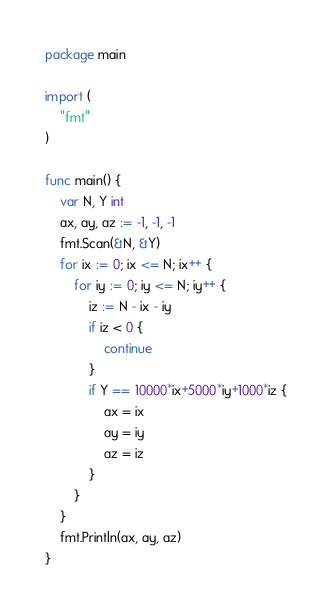<code> <loc_0><loc_0><loc_500><loc_500><_Go_>package main

import (
	"fmt"
)

func main() {
	var N, Y int
	ax, ay, az := -1, -1, -1
	fmt.Scan(&N, &Y)
	for ix := 0; ix <= N; ix++ {
		for iy := 0; iy <= N; iy++ {
			iz := N - ix - iy
			if iz < 0 {
				continue
			}
			if Y == 10000*ix+5000*iy+1000*iz {
				ax = ix
				ay = iy
				az = iz
			}
		}
	}
	fmt.Println(ax, ay, az)
}
</code> 